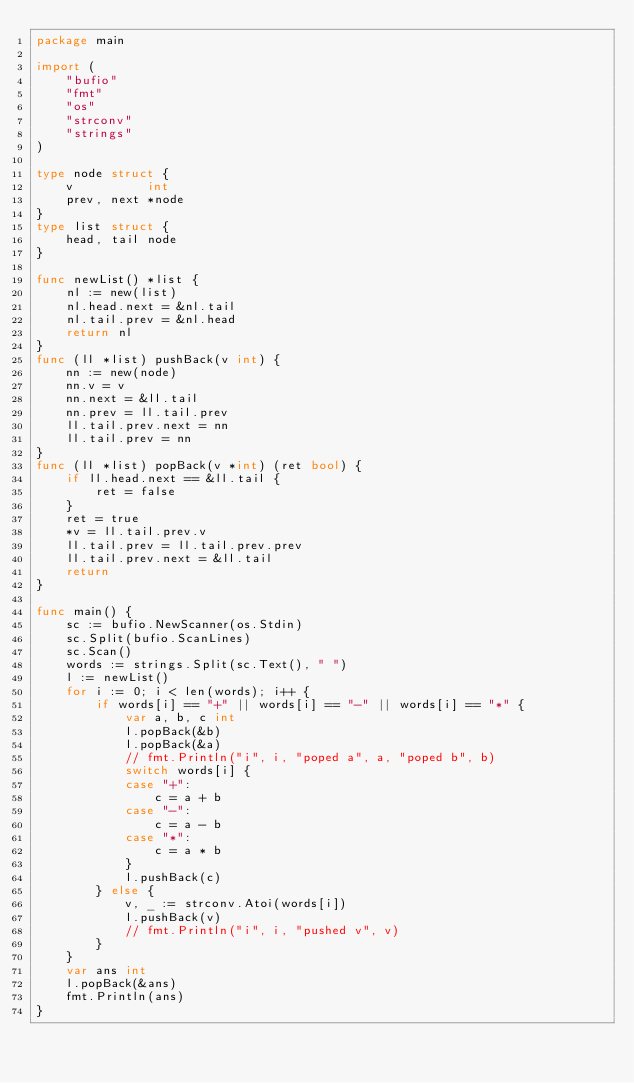<code> <loc_0><loc_0><loc_500><loc_500><_Go_>package main

import (
	"bufio"
	"fmt"
	"os"
	"strconv"
	"strings"
)

type node struct {
	v          int
	prev, next *node
}
type list struct {
	head, tail node
}

func newList() *list {
	nl := new(list)
	nl.head.next = &nl.tail
	nl.tail.prev = &nl.head
	return nl
}
func (ll *list) pushBack(v int) {
	nn := new(node)
	nn.v = v
	nn.next = &ll.tail
	nn.prev = ll.tail.prev
	ll.tail.prev.next = nn
	ll.tail.prev = nn
}
func (ll *list) popBack(v *int) (ret bool) {
	if ll.head.next == &ll.tail {
		ret = false
	}
	ret = true
	*v = ll.tail.prev.v
	ll.tail.prev = ll.tail.prev.prev
	ll.tail.prev.next = &ll.tail
	return
}

func main() {
	sc := bufio.NewScanner(os.Stdin)
	sc.Split(bufio.ScanLines)
	sc.Scan()
	words := strings.Split(sc.Text(), " ")
	l := newList()
	for i := 0; i < len(words); i++ {
		if words[i] == "+" || words[i] == "-" || words[i] == "*" {
			var a, b, c int
			l.popBack(&b)
			l.popBack(&a)
			// fmt.Println("i", i, "poped a", a, "poped b", b)
			switch words[i] {
			case "+":
				c = a + b
			case "-":
				c = a - b
			case "*":
				c = a * b
			}
			l.pushBack(c)
		} else {
			v, _ := strconv.Atoi(words[i])
			l.pushBack(v)
			// fmt.Println("i", i, "pushed v", v)
		}
	}
	var ans int
	l.popBack(&ans)
	fmt.Println(ans)
}

</code> 